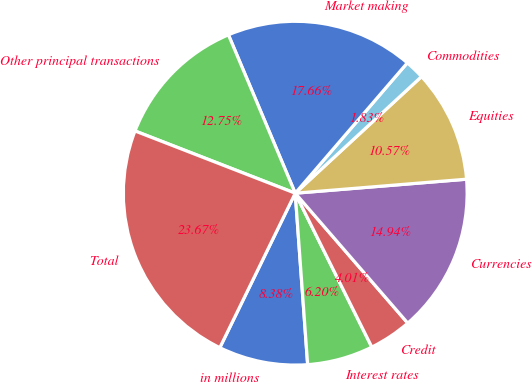Convert chart to OTSL. <chart><loc_0><loc_0><loc_500><loc_500><pie_chart><fcel>in millions<fcel>Interest rates<fcel>Credit<fcel>Currencies<fcel>Equities<fcel>Commodities<fcel>Market making<fcel>Other principal transactions<fcel>Total<nl><fcel>8.38%<fcel>6.2%<fcel>4.01%<fcel>14.94%<fcel>10.57%<fcel>1.83%<fcel>17.66%<fcel>12.75%<fcel>23.67%<nl></chart> 